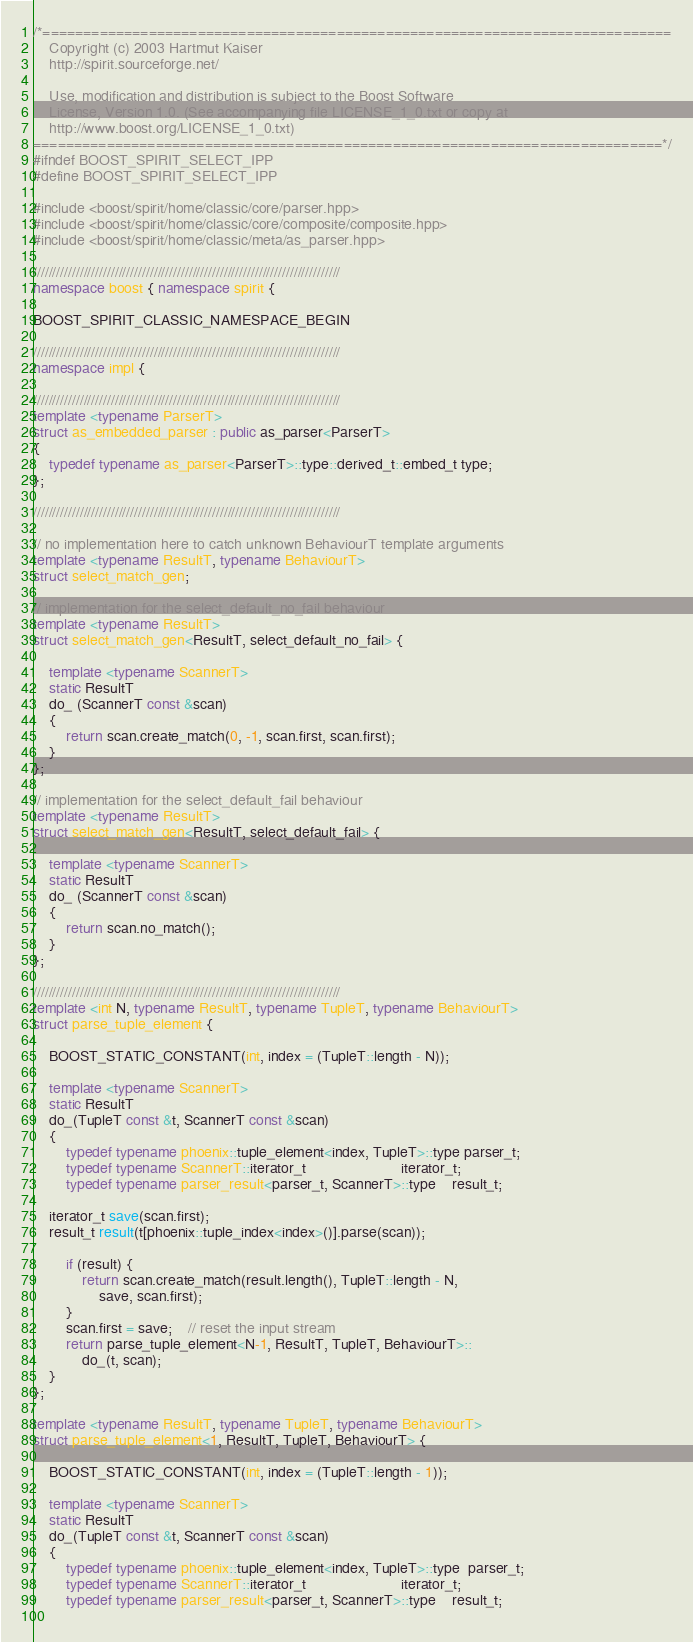<code> <loc_0><loc_0><loc_500><loc_500><_C++_>/*=============================================================================
    Copyright (c) 2003 Hartmut Kaiser
    http://spirit.sourceforge.net/

    Use, modification and distribution is subject to the Boost Software
    License, Version 1.0. (See accompanying file LICENSE_1_0.txt or copy at
    http://www.boost.org/LICENSE_1_0.txt)
=============================================================================*/
#ifndef BOOST_SPIRIT_SELECT_IPP
#define BOOST_SPIRIT_SELECT_IPP

#include <boost/spirit/home/classic/core/parser.hpp>
#include <boost/spirit/home/classic/core/composite/composite.hpp>
#include <boost/spirit/home/classic/meta/as_parser.hpp>

///////////////////////////////////////////////////////////////////////////////
namespace boost { namespace spirit {

BOOST_SPIRIT_CLASSIC_NAMESPACE_BEGIN

///////////////////////////////////////////////////////////////////////////////
namespace impl {

///////////////////////////////////////////////////////////////////////////////
template <typename ParserT>
struct as_embedded_parser : public as_parser<ParserT>
{
    typedef typename as_parser<ParserT>::type::derived_t::embed_t type;
};

///////////////////////////////////////////////////////////////////////////////

// no implementation here to catch unknown BehaviourT template arguments
template <typename ResultT, typename BehaviourT>
struct select_match_gen;

// implementation for the select_default_no_fail behaviour
template <typename ResultT>
struct select_match_gen<ResultT, select_default_no_fail> {

    template <typename ScannerT>
    static ResultT
    do_ (ScannerT const &scan)
    {
        return scan.create_match(0, -1, scan.first, scan.first);
    }
};

// implementation for the select_default_fail behaviour
template <typename ResultT>
struct select_match_gen<ResultT, select_default_fail> {

    template <typename ScannerT>
    static ResultT
    do_ (ScannerT const &scan)
    {
        return scan.no_match();
    }
};

///////////////////////////////////////////////////////////////////////////////
template <int N, typename ResultT, typename TupleT, typename BehaviourT>
struct parse_tuple_element {

    BOOST_STATIC_CONSTANT(int, index = (TupleT::length - N));
    
    template <typename ScannerT>
    static ResultT
    do_(TupleT const &t, ScannerT const &scan)
    {
        typedef typename phoenix::tuple_element<index, TupleT>::type parser_t;
        typedef typename ScannerT::iterator_t                       iterator_t;
        typedef typename parser_result<parser_t, ScannerT>::type    result_t;
    
    iterator_t save(scan.first);
    result_t result(t[phoenix::tuple_index<index>()].parse(scan));

        if (result) {
            return scan.create_match(result.length(), TupleT::length - N, 
                save, scan.first);
        }
        scan.first = save;    // reset the input stream 
        return parse_tuple_element<N-1, ResultT, TupleT, BehaviourT>::
            do_(t, scan);
    }
};

template <typename ResultT, typename TupleT, typename BehaviourT>
struct parse_tuple_element<1, ResultT, TupleT, BehaviourT> {

    BOOST_STATIC_CONSTANT(int, index = (TupleT::length - 1));
    
    template <typename ScannerT>
    static ResultT
    do_(TupleT const &t, ScannerT const &scan)
    {
        typedef typename phoenix::tuple_element<index, TupleT>::type  parser_t;
        typedef typename ScannerT::iterator_t                       iterator_t;
        typedef typename parser_result<parser_t, ScannerT>::type    result_t;
        </code> 